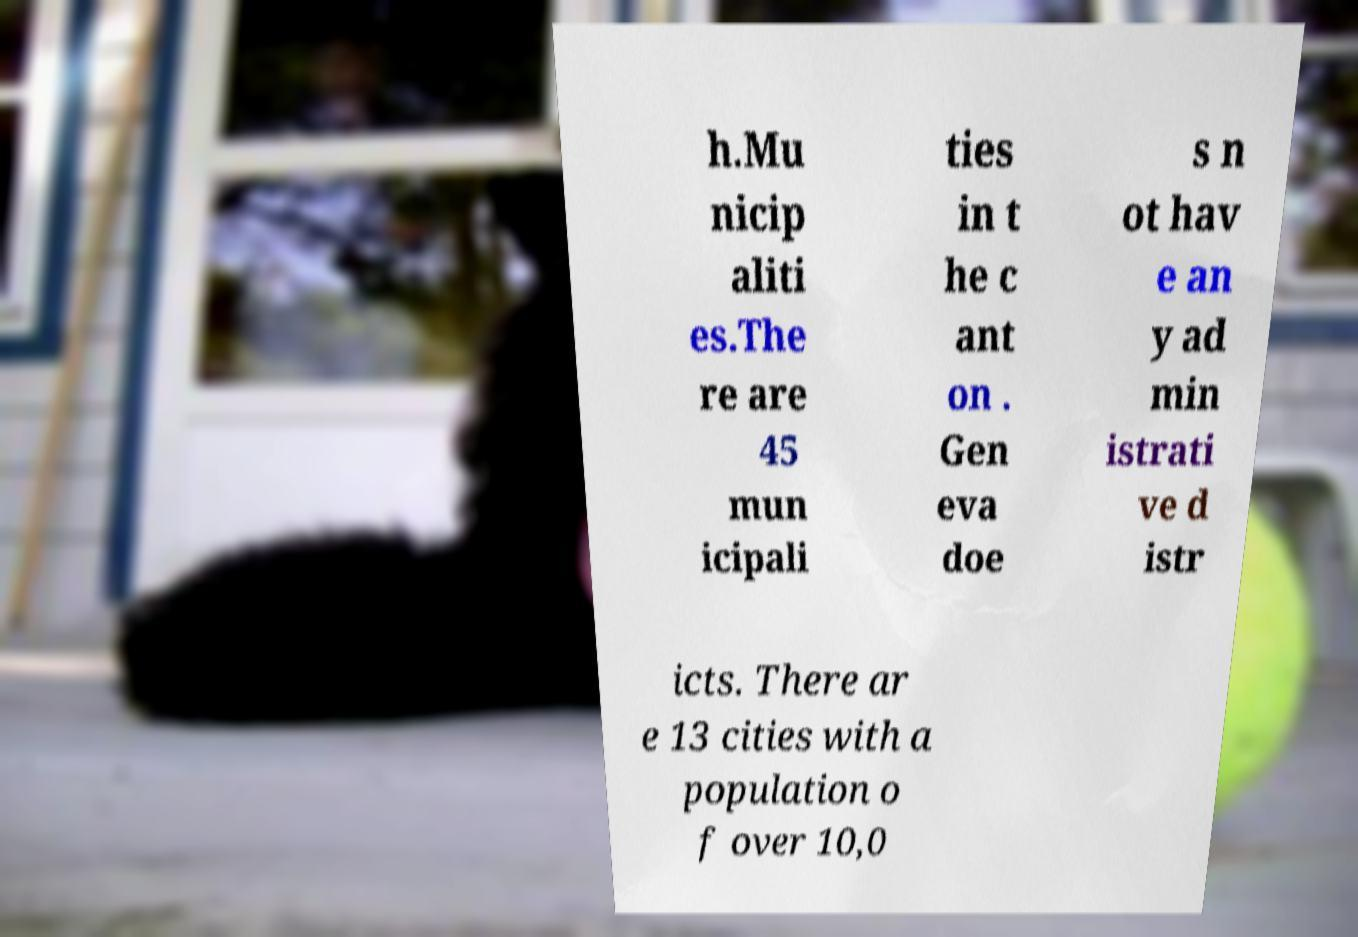For documentation purposes, I need the text within this image transcribed. Could you provide that? h.Mu nicip aliti es.The re are 45 mun icipali ties in t he c ant on . Gen eva doe s n ot hav e an y ad min istrati ve d istr icts. There ar e 13 cities with a population o f over 10,0 